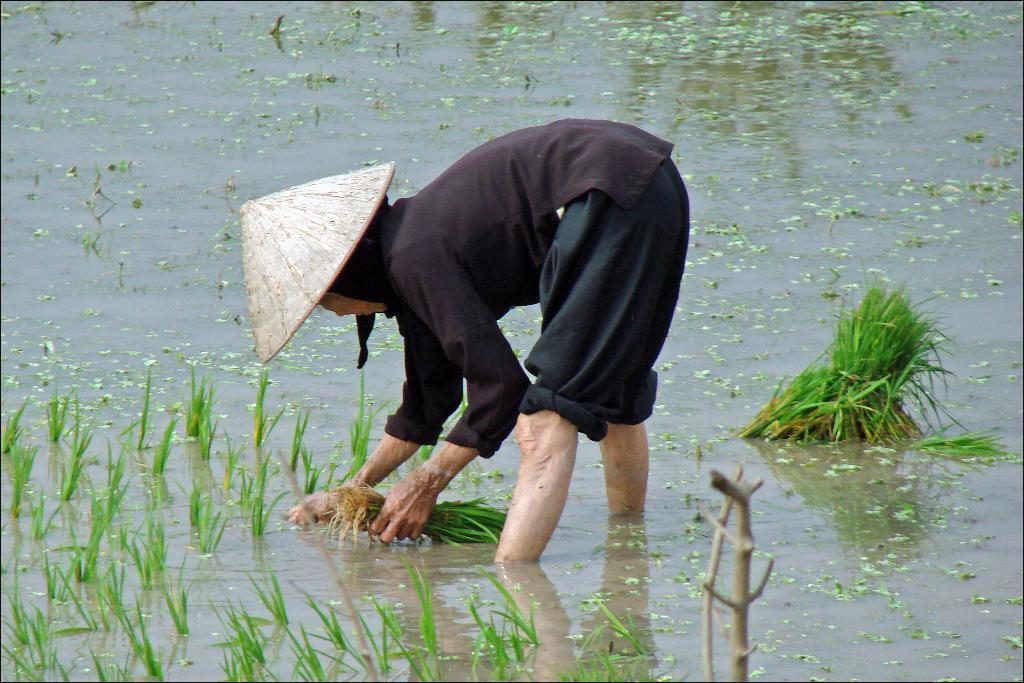What is the person in the image doing? The person in the image is planting. What can be seen at the bottom of the image? There is water at the bottom of the image. What type of vegetation is visible in the image? There is grass visible in the image. Can you see any yams growing in the image? There is no yam visible in the image. Are there any icicles hanging from the grass in the image? There are no icicles present in the image. 